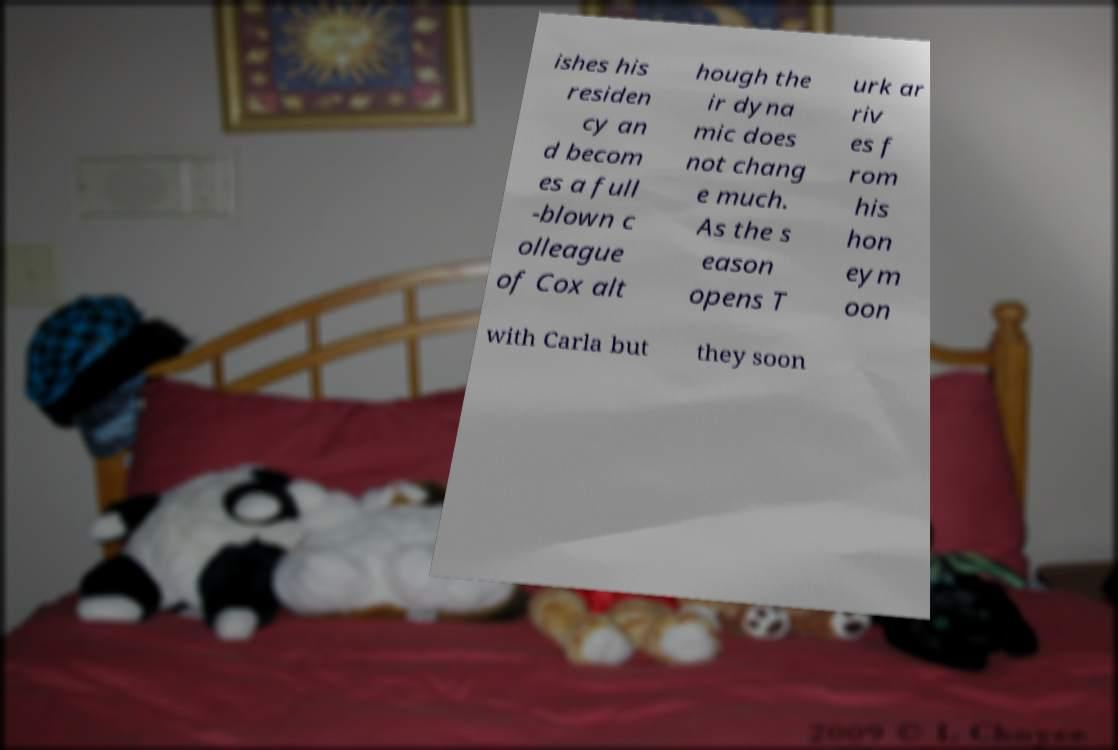Please identify and transcribe the text found in this image. ishes his residen cy an d becom es a full -blown c olleague of Cox alt hough the ir dyna mic does not chang e much. As the s eason opens T urk ar riv es f rom his hon eym oon with Carla but they soon 